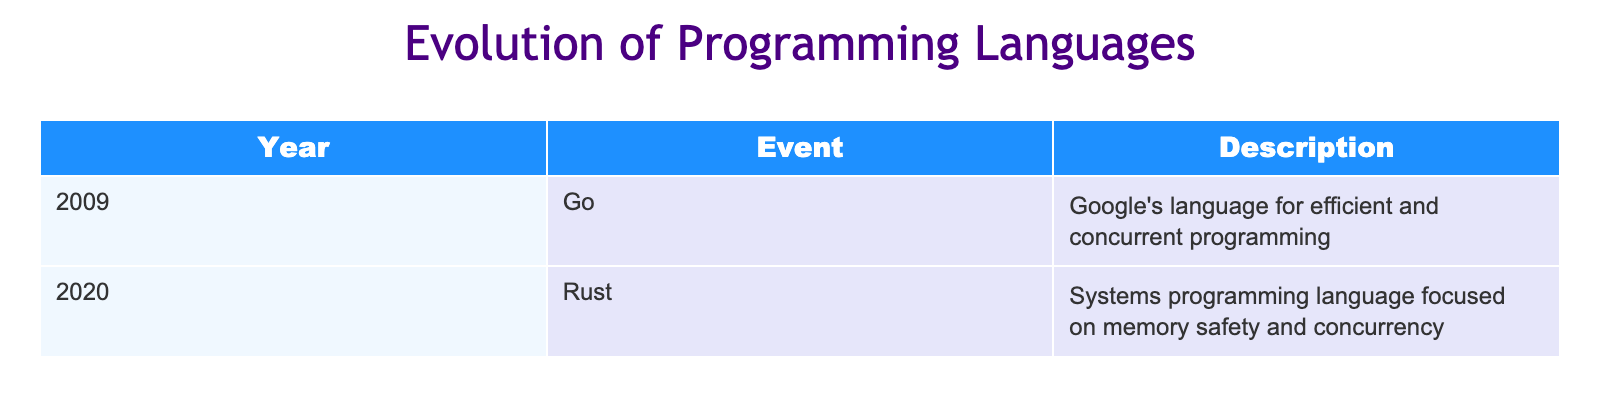What programming language was introduced in 2009? The table shows an entry for the year 2009 in the "Year" column, with the corresponding "Event" identifying the programming language as Go.
Answer: Go Which programming language focuses on memory safety? The table lists Rust under the year 2020, and the description specifically mentions memory safety as a focus of the language.
Answer: Rust In which year was the language Go introduced? By looking at the table, the "Year" entry across from the "Go" event reveals that it was introduced in 2009.
Answer: 2009 How many programming languages are listed in the table? The table has two rows, each representing a different programming language introduced in different years. Thus, the total is counted as 2.
Answer: 2 Is Rust introduced before or after Go? Comparing the years in the table, Go was introduced in 2009 and Rust in 2020. Since 2009 is earlier than 2020, Rust was introduced after Go.
Answer: After What is the difference in years between the introduction of Go and Rust? The year for Go is 2009 and for Rust is 2020. The difference is calculated by subtracting 2009 from 2020, which equals 11 years.
Answer: 11 years Does the table indicate the languages are focused on concurrent programming? Both Go and Rust descriptions mention concurrency. Therefore, the answer is yes, the table indicates that the languages focus on concurrent programming.
Answer: Yes Which programming language in the table was developed by Google? The description next to Go states that it was developed by Google, making it the distinct entry that matches this criterion.
Answer: Go Was any programming language mentioned in the table released in the 2000s? The table clearly states that Go was created in 2009, which falls in the 2000s decade, confirming that at least one programming language is from that period.
Answer: Yes 